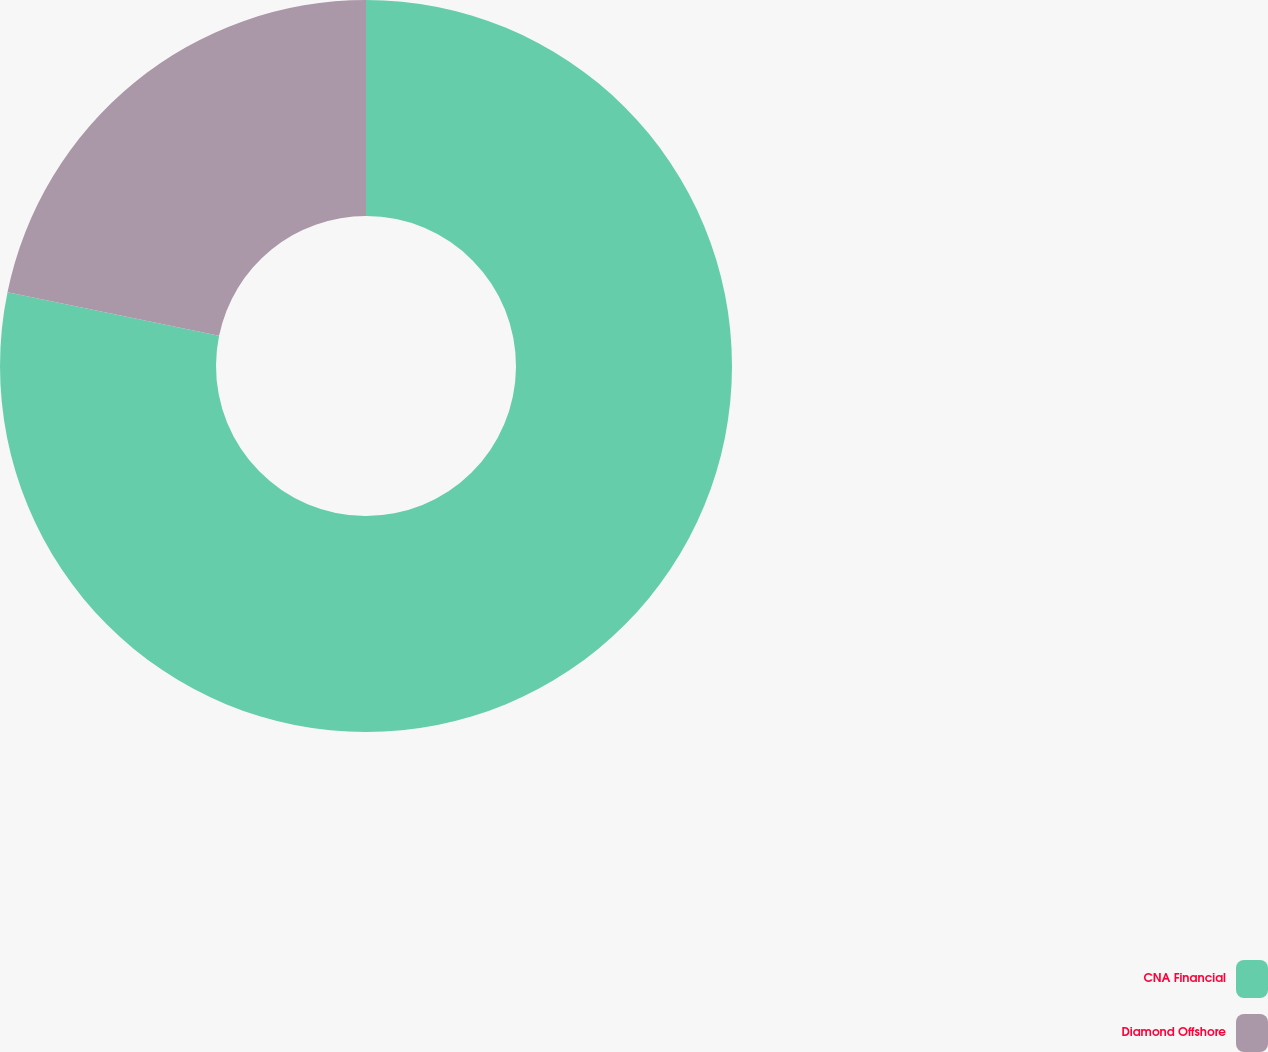Convert chart to OTSL. <chart><loc_0><loc_0><loc_500><loc_500><pie_chart><fcel>CNA Financial<fcel>Diamond Offshore<nl><fcel>78.23%<fcel>21.77%<nl></chart> 